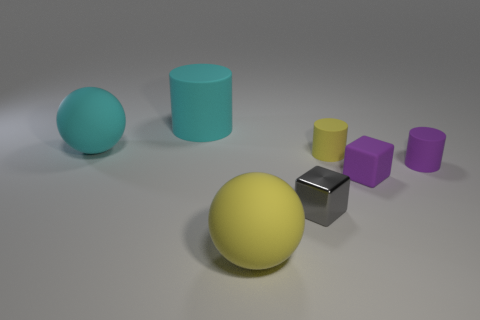What number of small metallic things have the same shape as the small yellow rubber object?
Offer a terse response. 0. The matte cube has what size?
Give a very brief answer. Small. How many cyan matte things have the same size as the yellow rubber sphere?
Your answer should be compact. 2. There is a purple rubber thing left of the tiny purple matte cylinder; does it have the same size as the gray thing in front of the big cyan cylinder?
Your answer should be compact. Yes. The yellow thing that is on the right side of the tiny gray shiny thing has what shape?
Give a very brief answer. Cylinder. The big yellow thing that is on the left side of the shiny block in front of the tiny yellow matte object is made of what material?
Ensure brevity in your answer.  Rubber. Is there a cylinder of the same color as the matte block?
Provide a succinct answer. Yes. There is a purple cylinder; is its size the same as the cyan rubber object that is in front of the cyan cylinder?
Your response must be concise. No. How many tiny yellow cylinders are behind the ball that is in front of the tiny matte thing behind the purple rubber cylinder?
Your answer should be very brief. 1. There is a purple rubber block; what number of big cyan spheres are to the right of it?
Keep it short and to the point. 0. 